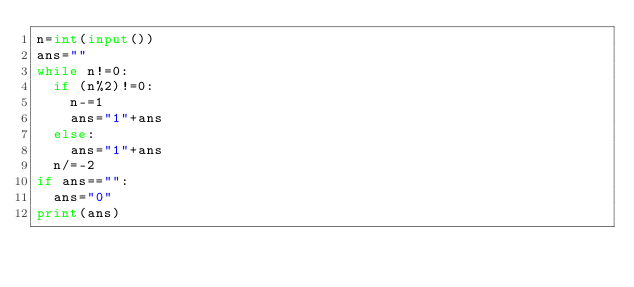Convert code to text. <code><loc_0><loc_0><loc_500><loc_500><_Python_>n=int(input())
ans=""
while n!=0:
  if (n%2)!=0:
    n-=1
    ans="1"+ans
  else:
    ans="1"+ans
  n/=-2
if ans=="":
  ans="0"
print(ans)</code> 